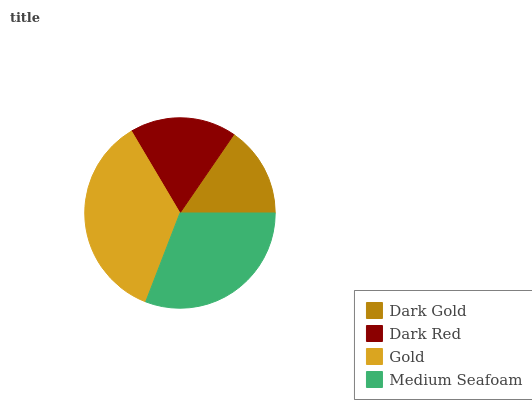Is Dark Gold the minimum?
Answer yes or no. Yes. Is Gold the maximum?
Answer yes or no. Yes. Is Dark Red the minimum?
Answer yes or no. No. Is Dark Red the maximum?
Answer yes or no. No. Is Dark Red greater than Dark Gold?
Answer yes or no. Yes. Is Dark Gold less than Dark Red?
Answer yes or no. Yes. Is Dark Gold greater than Dark Red?
Answer yes or no. No. Is Dark Red less than Dark Gold?
Answer yes or no. No. Is Medium Seafoam the high median?
Answer yes or no. Yes. Is Dark Red the low median?
Answer yes or no. Yes. Is Dark Red the high median?
Answer yes or no. No. Is Gold the low median?
Answer yes or no. No. 